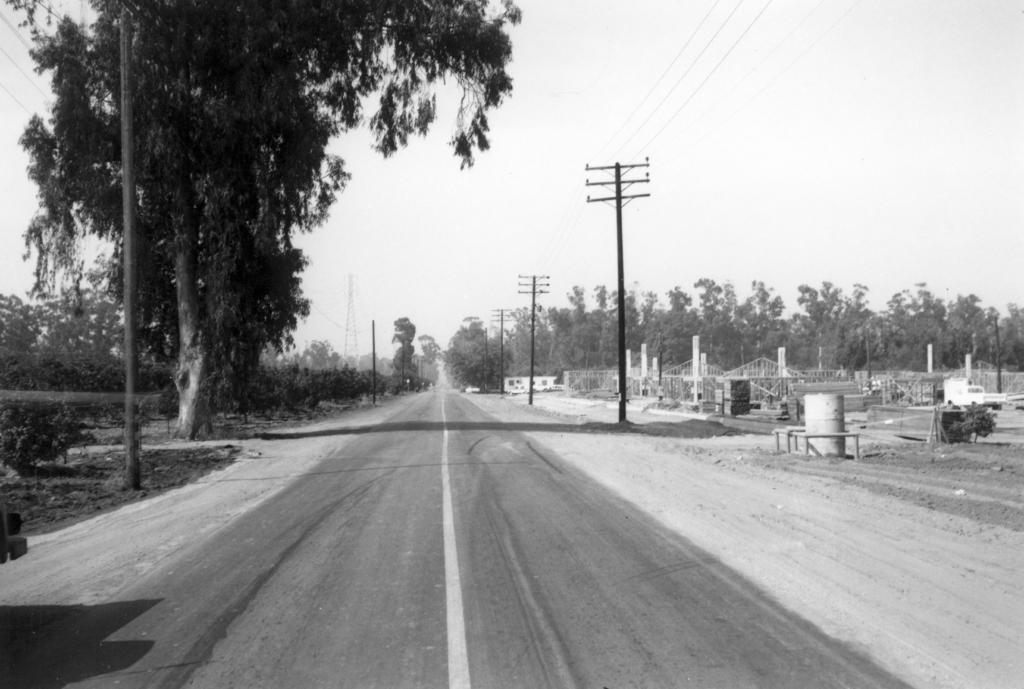What type of natural elements can be seen in the image? There are trees in the image. What man-made structures are present in the image? There are poles and electrical poles in the image. What type of ground surface is visible in the image? There is a road visible in the image. What type of vegetation is present on the ground in the image? There are plants on the ground in the image. What is the condition of the sky in the image? The sky is cloudy in the image. What type of shoes can be seen on the trees in the image? There are no shoes present in the image, and shoes are not typically found on trees. Can you describe the romantic interaction between the trees in the image? There is no romantic interaction depicted in the image, as it features trees, poles, and a road. 